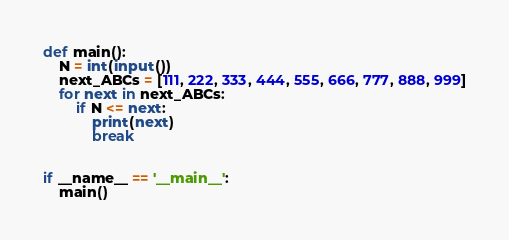<code> <loc_0><loc_0><loc_500><loc_500><_Python_>def main():
    N = int(input())
    next_ABCs = [111, 222, 333, 444, 555, 666, 777, 888, 999]
    for next in next_ABCs:
        if N <= next:
            print(next)
            break


if __name__ == '__main__':
    main()</code> 